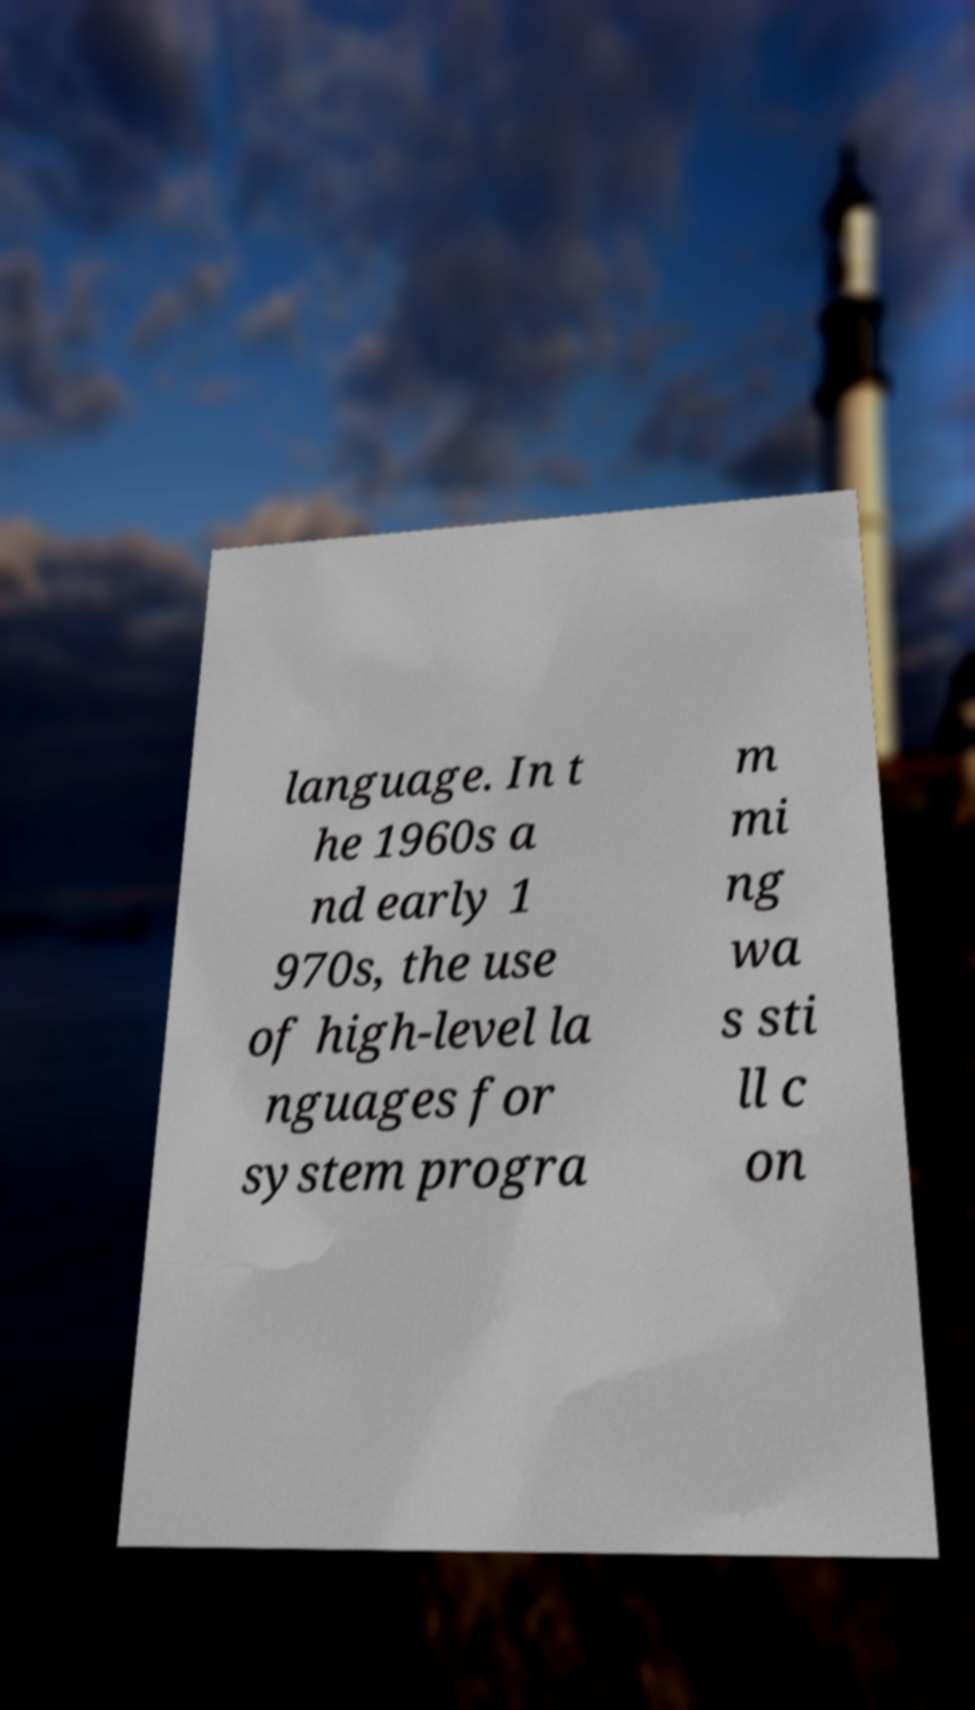Could you assist in decoding the text presented in this image and type it out clearly? language. In t he 1960s a nd early 1 970s, the use of high-level la nguages for system progra m mi ng wa s sti ll c on 